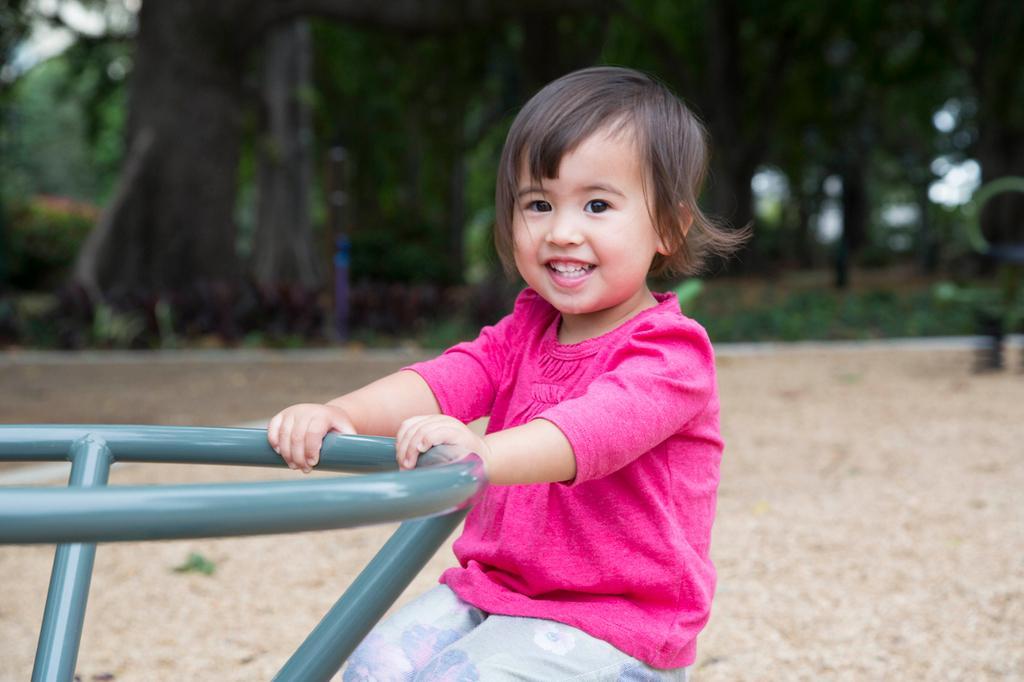Describe this image in one or two sentences. In this image we can see a kid smiling and sitting and also holding an object. In the background we can see the land and also the trees. 